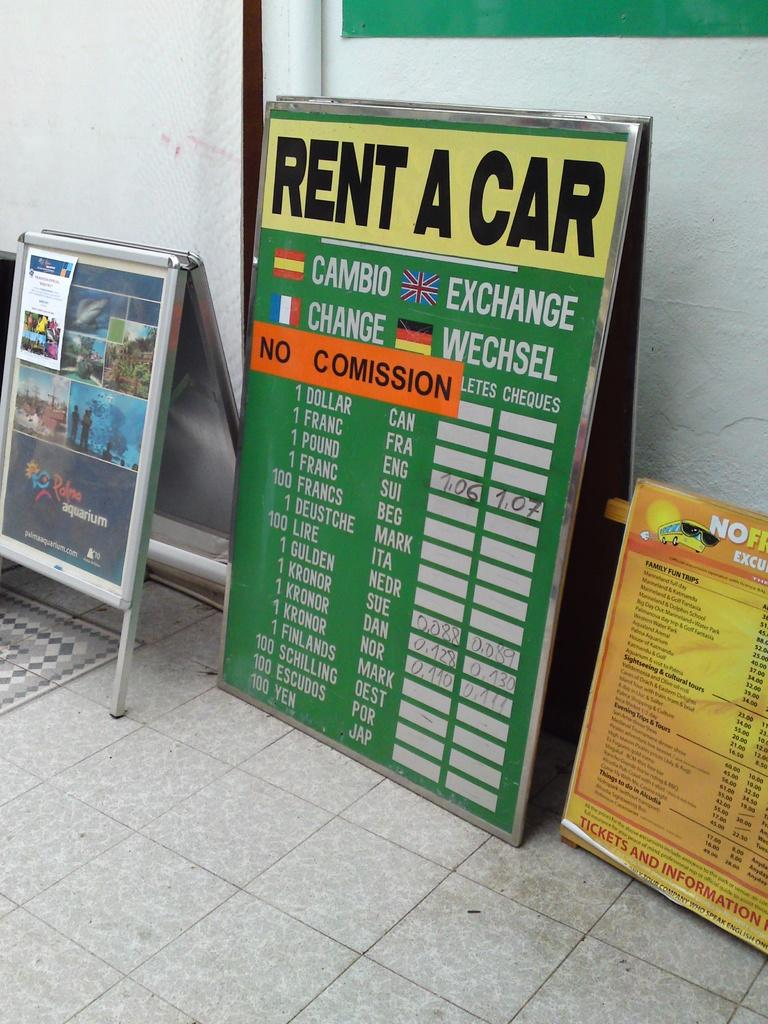<image>
Present a compact description of the photo's key features. A large green rent a car sign is propped up against a wall between two other signs. 